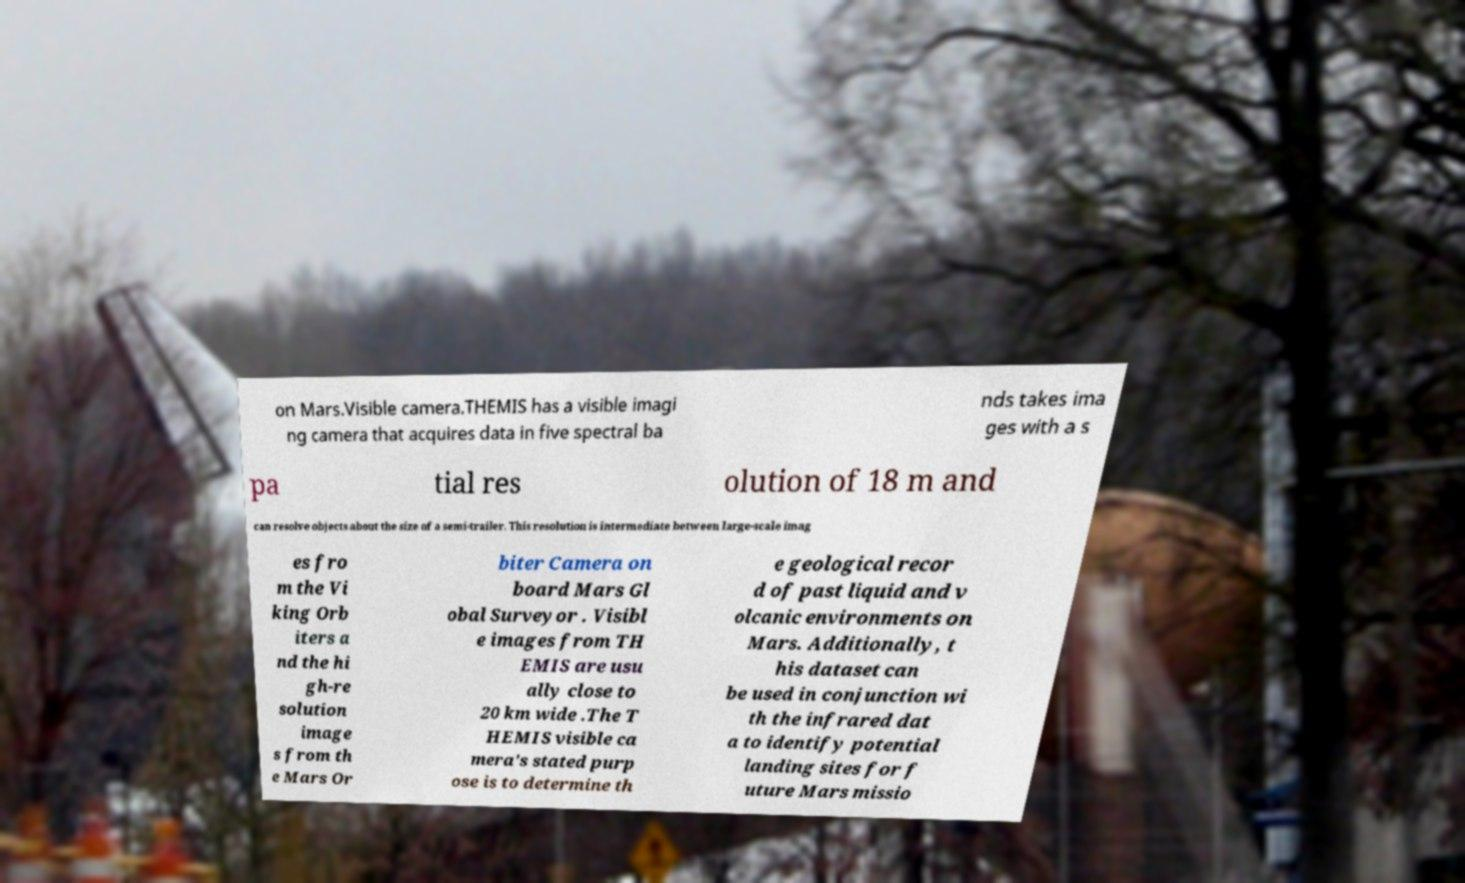Can you read and provide the text displayed in the image?This photo seems to have some interesting text. Can you extract and type it out for me? on Mars.Visible camera.THEMIS has a visible imagi ng camera that acquires data in five spectral ba nds takes ima ges with a s pa tial res olution of 18 m and can resolve objects about the size of a semi-trailer. This resolution is intermediate between large-scale imag es fro m the Vi king Orb iters a nd the hi gh-re solution image s from th e Mars Or biter Camera on board Mars Gl obal Surveyor . Visibl e images from TH EMIS are usu ally close to 20 km wide .The T HEMIS visible ca mera's stated purp ose is to determine th e geological recor d of past liquid and v olcanic environments on Mars. Additionally, t his dataset can be used in conjunction wi th the infrared dat a to identify potential landing sites for f uture Mars missio 